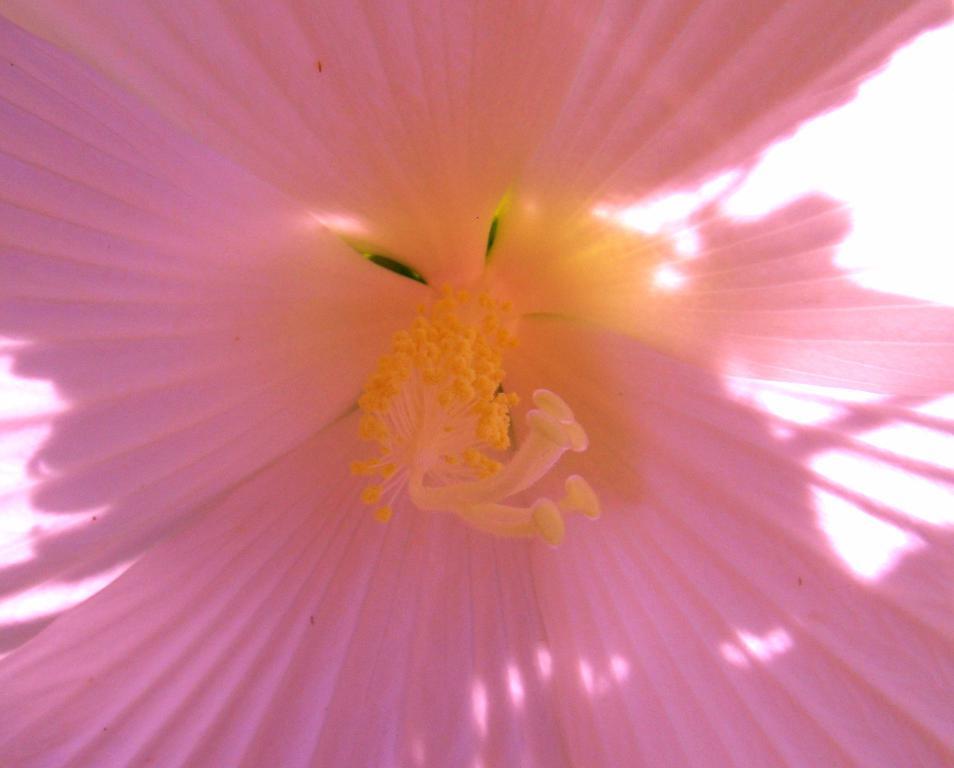How would you summarize this image in a sentence or two? This is a zoomed image of a flower. 